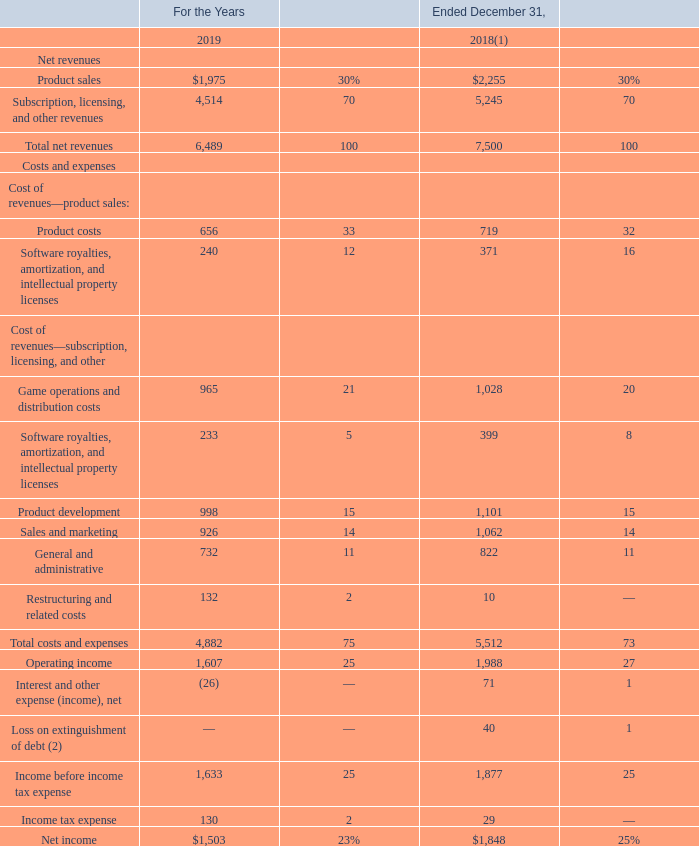Consolidated Statements of Operations Data
The following table sets forth consolidated statements of operations data for the periods indicated (amounts in millions) and as a percentage of total net revenues, except for cost of revenues, which are presented as a percentage of associated revenues:
(1) During the three months ended March 31, 2019, we identified an amount which should have been recorded in the three months and year ended December 31, 2018 to reduce income tax expense by $35 million. Our statement of operations for the year ended December 31, 2018, as presented above, has been revised to reflect the correction. See further discussion in Note 2 of the notes to the consolidated financial statements included in Item 8 of this Annual Report on Form 10-K.
(2) Represents the loss on extinguishment of debt we recognized in connection with our debt financing activities during the year ended December 31, 2018. The loss on extinguishment is comprised of a $25 million premium payment and a $15 million write-off of unamortized discount and deferred financing costs.
What does the loss on extinguishment comprise of? A $25 million premium payment and a $15 million write-off of unamortized discount and deferred financing costs. What was net income in 2019?
Answer scale should be: million. $1,503. What was net income in 2018?
Answer scale should be: million. $1,848. What is the percentage change in product costs between 2018 and 2019?
Answer scale should be: percent. (656-719)/719
Answer: -8.76. What is the percentage change in operating income between 2018 and 2019?
Answer scale should be: percent. (1,607-1,988)/1,988
Answer: -19.16. What is the difference in game operations and distribution costs between 2018 and 2019?
Answer scale should be: million. (1,028-965)
Answer: 63. 